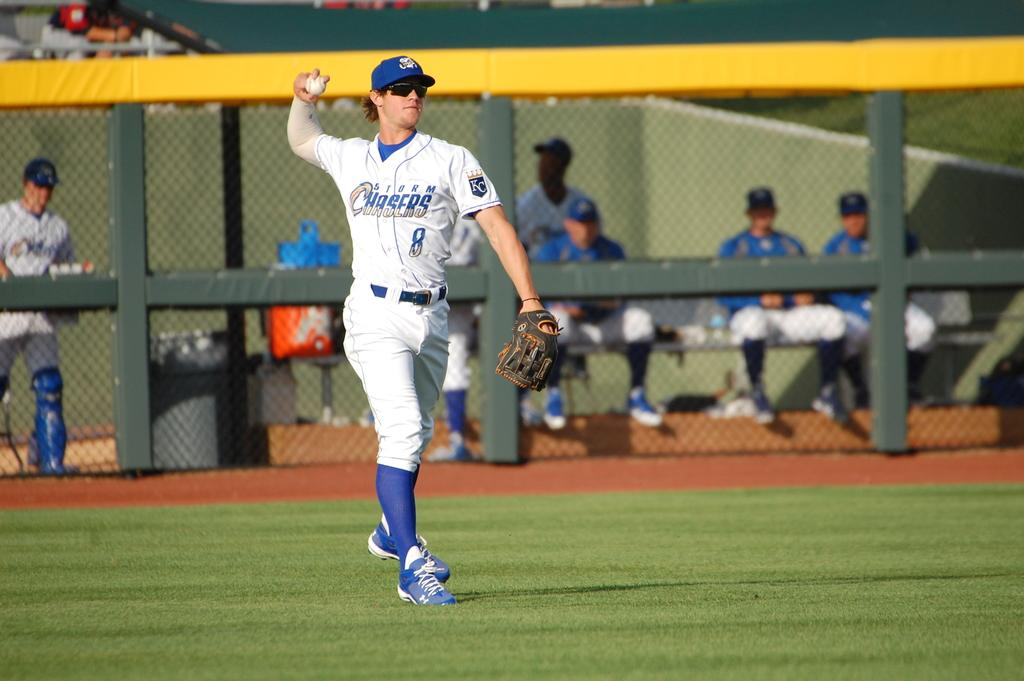<image>
Write a terse but informative summary of the picture. A baseball player in a Chasers uniform throwing a ball. 